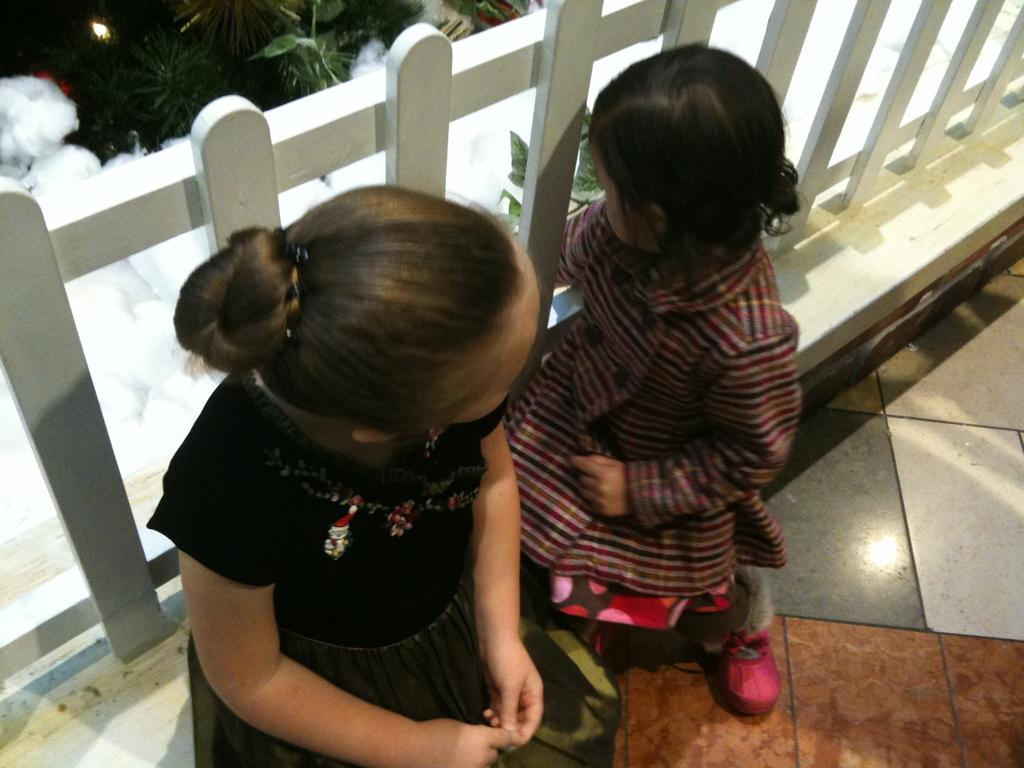What are the kids doing in the image? The kids are sitting in the image. What can be seen beneath the kids? The floor is visible in the image. What type of material is the railing made of? The railing in the image is made of wood. What is the texture of the cotton in the image? The cotton in the image has a soft and fluffy texture. What type of vegetation is present in the image? Plants are visible in the image. What type of spark can be seen coming from the cotton in the image? There is no spark present in the image; the cotton is not on fire or producing any sparks. 